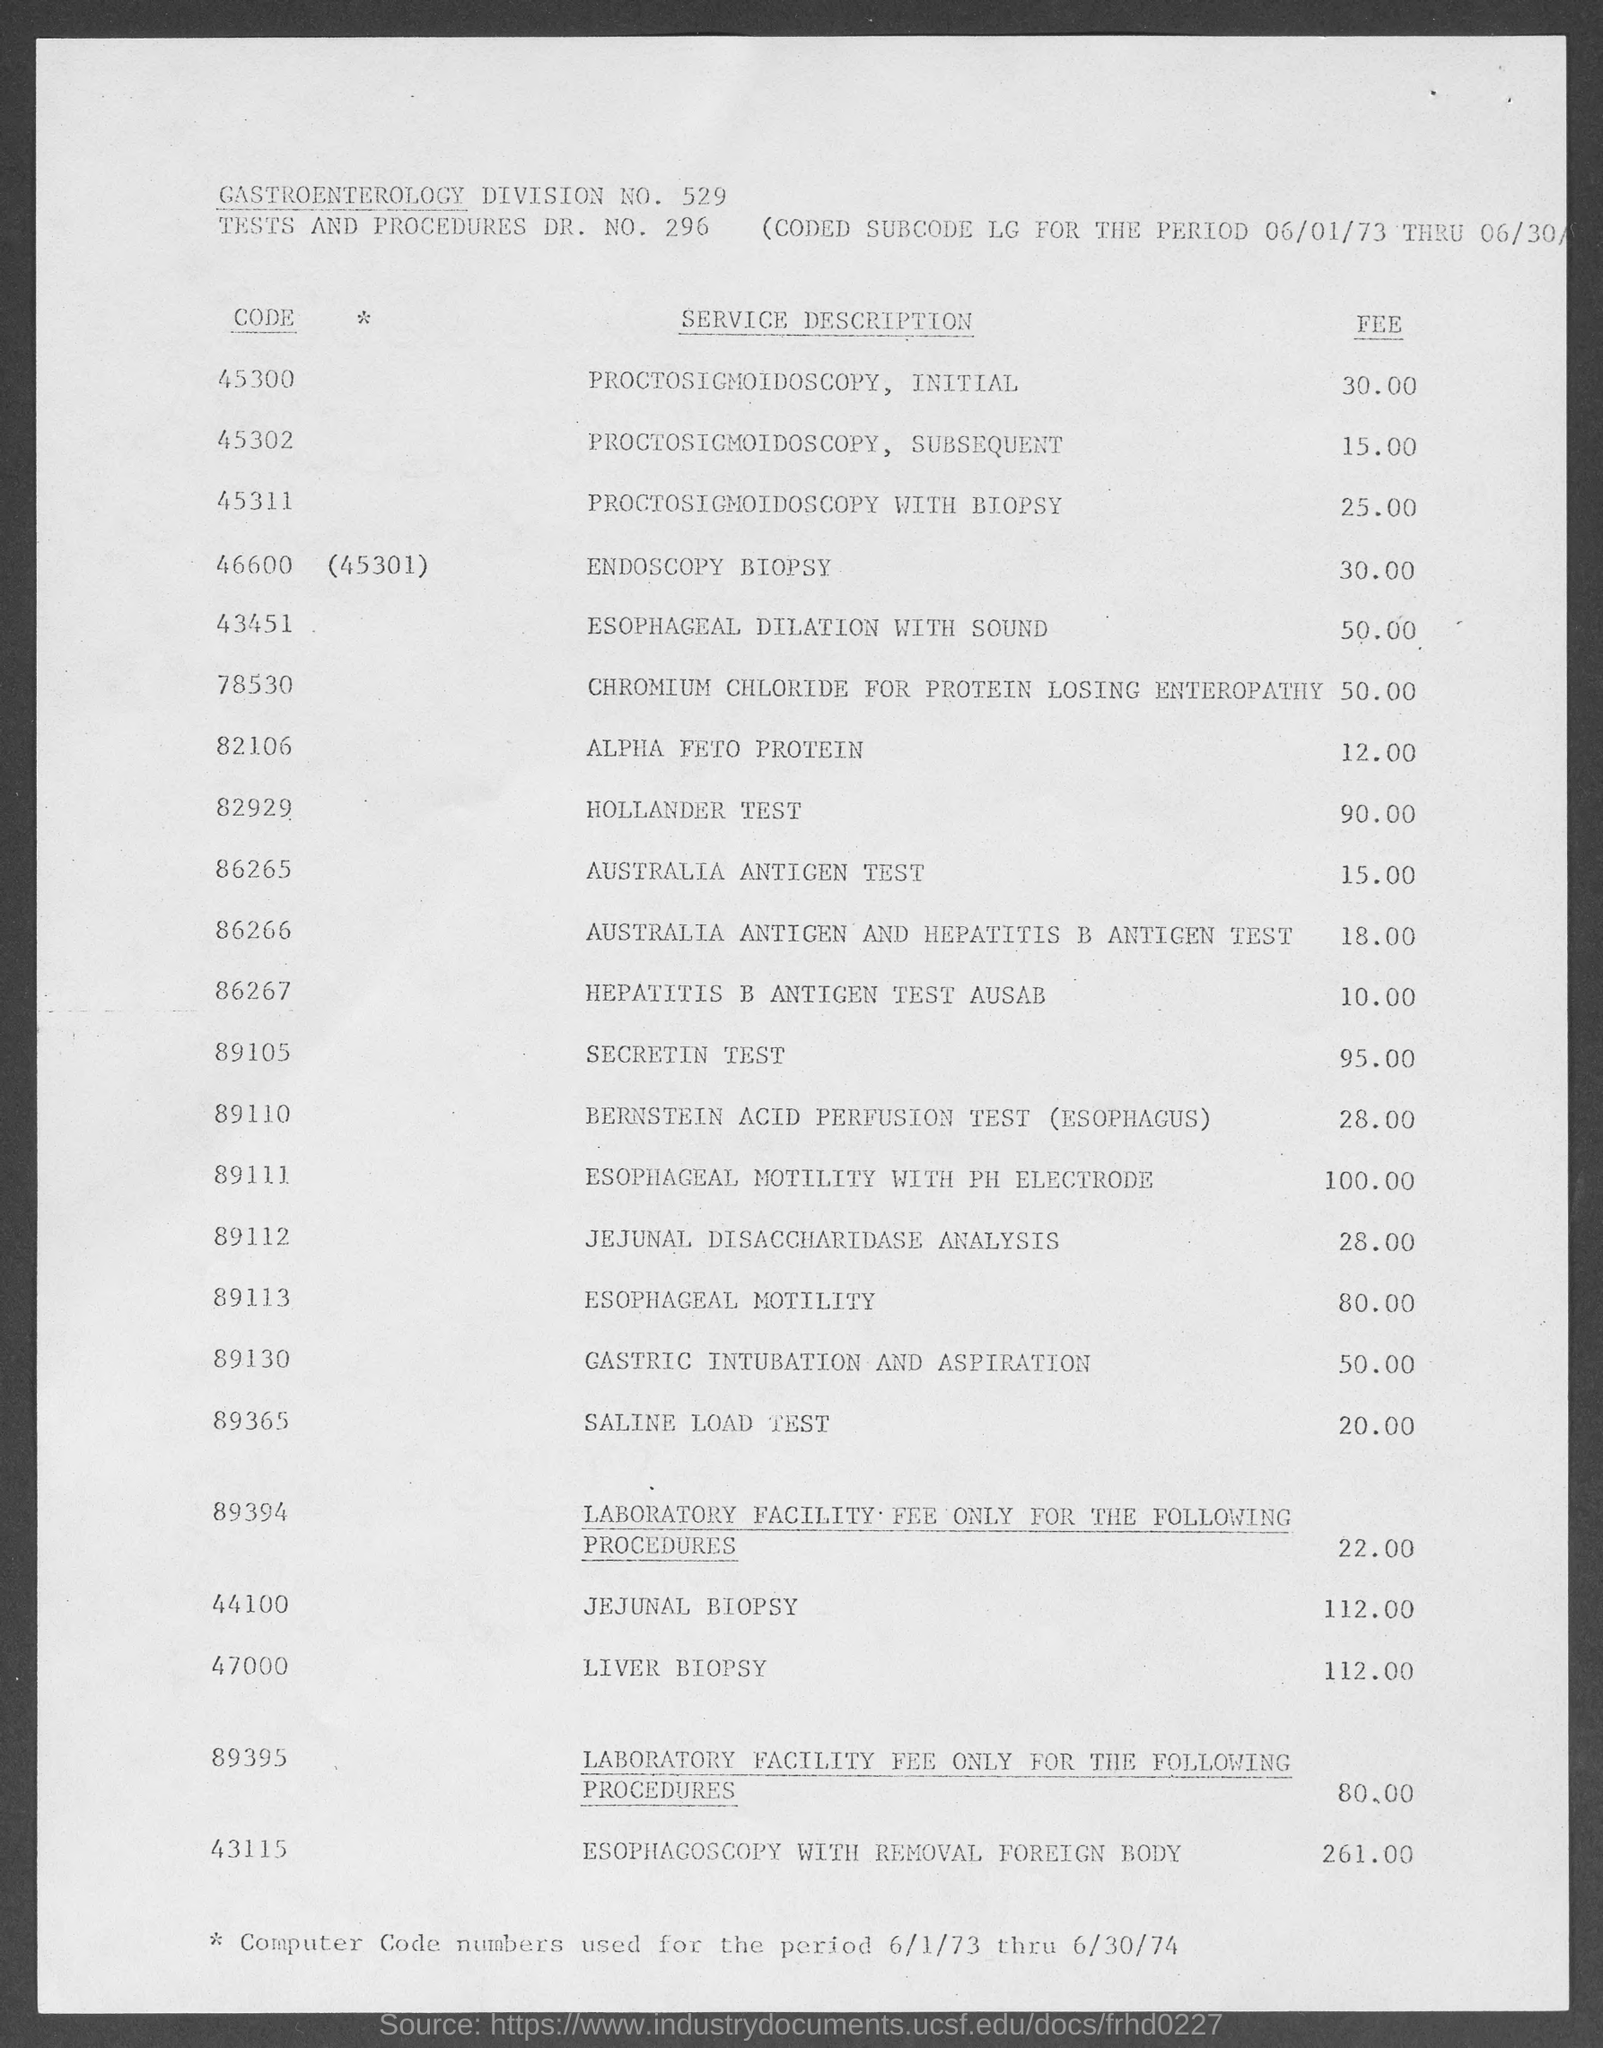What is the Tests and Procedures Dr. No. given in the document?
Ensure brevity in your answer.  296. What is the Gastroenterology Division No. given in the document?
Offer a terse response. 529. What is the Code mentioned for Hollander Test?
Offer a terse response. 82929. What is the fee charged for Secretin Test?
Give a very brief answer. 95.00. What is the fee charged for Saline Load Test?
Provide a succinct answer. 20.00. What is the Code mentioned for Liver Biopsy?
Ensure brevity in your answer.  47000. What is the fee charged for Jejunal Biopsy?
Provide a short and direct response. 112.00. 